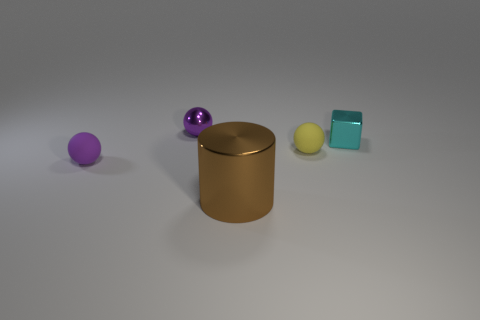Are there any other things that are the same size as the brown thing?
Offer a very short reply. No. Do the tiny shiny thing that is in front of the small purple shiny object and the large metal thing have the same shape?
Your response must be concise. No. What number of objects are either tiny purple spheres or tiny purple objects that are behind the cyan metal cube?
Offer a very short reply. 2. Is the number of things that are to the left of the large cylinder greater than the number of tiny gray rubber things?
Keep it short and to the point. Yes. Are there the same number of tiny matte objects behind the tiny cyan object and tiny yellow matte balls that are on the left side of the big metallic object?
Ensure brevity in your answer.  Yes. Is there a metal thing to the right of the small matte object that is to the right of the big cylinder?
Your response must be concise. Yes. What is the shape of the small yellow rubber thing?
Provide a short and direct response. Sphere. There is a thing that is the same color as the metal sphere; what is its size?
Offer a very short reply. Small. What is the size of the matte ball on the left side of the small metal object behind the cyan metal block?
Give a very brief answer. Small. What size is the purple thing behind the purple rubber ball?
Make the answer very short. Small. 